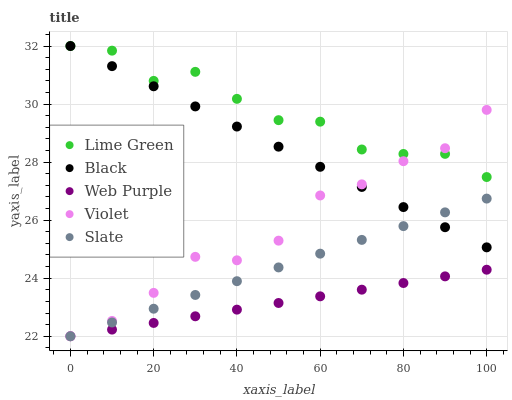Does Web Purple have the minimum area under the curve?
Answer yes or no. Yes. Does Lime Green have the maximum area under the curve?
Answer yes or no. Yes. Does Lime Green have the minimum area under the curve?
Answer yes or no. No. Does Web Purple have the maximum area under the curve?
Answer yes or no. No. Is Slate the smoothest?
Answer yes or no. Yes. Is Lime Green the roughest?
Answer yes or no. Yes. Is Web Purple the smoothest?
Answer yes or no. No. Is Web Purple the roughest?
Answer yes or no. No. Does Web Purple have the lowest value?
Answer yes or no. Yes. Does Lime Green have the lowest value?
Answer yes or no. No. Does Lime Green have the highest value?
Answer yes or no. Yes. Does Web Purple have the highest value?
Answer yes or no. No. Is Web Purple less than Lime Green?
Answer yes or no. Yes. Is Black greater than Web Purple?
Answer yes or no. Yes. Does Violet intersect Web Purple?
Answer yes or no. Yes. Is Violet less than Web Purple?
Answer yes or no. No. Is Violet greater than Web Purple?
Answer yes or no. No. Does Web Purple intersect Lime Green?
Answer yes or no. No. 